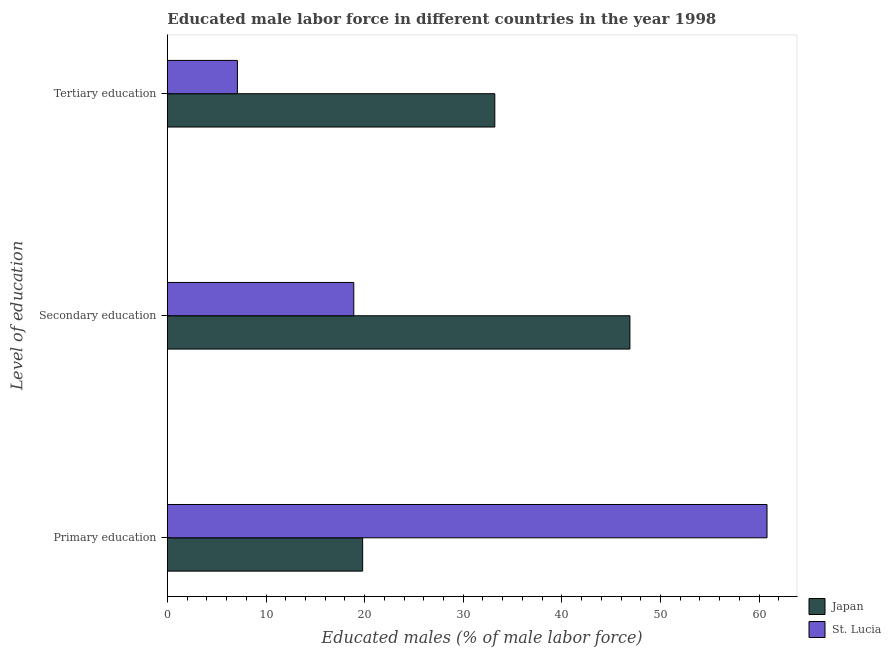How many different coloured bars are there?
Your answer should be compact. 2. How many bars are there on the 1st tick from the bottom?
Offer a very short reply. 2. What is the label of the 2nd group of bars from the top?
Give a very brief answer. Secondary education. What is the percentage of male labor force who received secondary education in St. Lucia?
Your answer should be very brief. 18.9. Across all countries, what is the maximum percentage of male labor force who received secondary education?
Make the answer very short. 46.9. Across all countries, what is the minimum percentage of male labor force who received primary education?
Offer a terse response. 19.8. In which country was the percentage of male labor force who received primary education maximum?
Your response must be concise. St. Lucia. What is the total percentage of male labor force who received primary education in the graph?
Make the answer very short. 80.6. What is the difference between the percentage of male labor force who received secondary education in Japan and that in St. Lucia?
Make the answer very short. 28. What is the difference between the percentage of male labor force who received tertiary education in Japan and the percentage of male labor force who received secondary education in St. Lucia?
Ensure brevity in your answer.  14.3. What is the average percentage of male labor force who received tertiary education per country?
Give a very brief answer. 20.15. What is the difference between the percentage of male labor force who received secondary education and percentage of male labor force who received tertiary education in Japan?
Give a very brief answer. 13.7. In how many countries, is the percentage of male labor force who received secondary education greater than 16 %?
Keep it short and to the point. 2. What is the ratio of the percentage of male labor force who received tertiary education in St. Lucia to that in Japan?
Provide a succinct answer. 0.21. Is the percentage of male labor force who received primary education in St. Lucia less than that in Japan?
Your answer should be very brief. No. What is the difference between the highest and the second highest percentage of male labor force who received secondary education?
Your answer should be compact. 28. What is the difference between the highest and the lowest percentage of male labor force who received tertiary education?
Keep it short and to the point. 26.1. In how many countries, is the percentage of male labor force who received secondary education greater than the average percentage of male labor force who received secondary education taken over all countries?
Keep it short and to the point. 1. Is the sum of the percentage of male labor force who received secondary education in Japan and St. Lucia greater than the maximum percentage of male labor force who received tertiary education across all countries?
Keep it short and to the point. Yes. What does the 2nd bar from the top in Secondary education represents?
Ensure brevity in your answer.  Japan. What does the 2nd bar from the bottom in Tertiary education represents?
Provide a short and direct response. St. Lucia. How many bars are there?
Ensure brevity in your answer.  6. Are all the bars in the graph horizontal?
Your answer should be compact. Yes. What is the difference between two consecutive major ticks on the X-axis?
Offer a very short reply. 10. Does the graph contain any zero values?
Ensure brevity in your answer.  No. Does the graph contain grids?
Your answer should be compact. No. What is the title of the graph?
Provide a succinct answer. Educated male labor force in different countries in the year 1998. What is the label or title of the X-axis?
Provide a succinct answer. Educated males (% of male labor force). What is the label or title of the Y-axis?
Keep it short and to the point. Level of education. What is the Educated males (% of male labor force) of Japan in Primary education?
Provide a short and direct response. 19.8. What is the Educated males (% of male labor force) of St. Lucia in Primary education?
Offer a very short reply. 60.8. What is the Educated males (% of male labor force) in Japan in Secondary education?
Your answer should be very brief. 46.9. What is the Educated males (% of male labor force) in St. Lucia in Secondary education?
Make the answer very short. 18.9. What is the Educated males (% of male labor force) of Japan in Tertiary education?
Make the answer very short. 33.2. What is the Educated males (% of male labor force) in St. Lucia in Tertiary education?
Offer a terse response. 7.1. Across all Level of education, what is the maximum Educated males (% of male labor force) in Japan?
Offer a very short reply. 46.9. Across all Level of education, what is the maximum Educated males (% of male labor force) of St. Lucia?
Your response must be concise. 60.8. Across all Level of education, what is the minimum Educated males (% of male labor force) of Japan?
Offer a very short reply. 19.8. Across all Level of education, what is the minimum Educated males (% of male labor force) of St. Lucia?
Your answer should be very brief. 7.1. What is the total Educated males (% of male labor force) in Japan in the graph?
Your answer should be very brief. 99.9. What is the total Educated males (% of male labor force) of St. Lucia in the graph?
Ensure brevity in your answer.  86.8. What is the difference between the Educated males (% of male labor force) in Japan in Primary education and that in Secondary education?
Ensure brevity in your answer.  -27.1. What is the difference between the Educated males (% of male labor force) in St. Lucia in Primary education and that in Secondary education?
Make the answer very short. 41.9. What is the difference between the Educated males (% of male labor force) of St. Lucia in Primary education and that in Tertiary education?
Ensure brevity in your answer.  53.7. What is the difference between the Educated males (% of male labor force) of Japan in Secondary education and that in Tertiary education?
Give a very brief answer. 13.7. What is the difference between the Educated males (% of male labor force) in Japan in Primary education and the Educated males (% of male labor force) in St. Lucia in Secondary education?
Your response must be concise. 0.9. What is the difference between the Educated males (% of male labor force) in Japan in Primary education and the Educated males (% of male labor force) in St. Lucia in Tertiary education?
Provide a succinct answer. 12.7. What is the difference between the Educated males (% of male labor force) of Japan in Secondary education and the Educated males (% of male labor force) of St. Lucia in Tertiary education?
Your answer should be very brief. 39.8. What is the average Educated males (% of male labor force) in Japan per Level of education?
Make the answer very short. 33.3. What is the average Educated males (% of male labor force) in St. Lucia per Level of education?
Offer a terse response. 28.93. What is the difference between the Educated males (% of male labor force) of Japan and Educated males (% of male labor force) of St. Lucia in Primary education?
Your response must be concise. -41. What is the difference between the Educated males (% of male labor force) of Japan and Educated males (% of male labor force) of St. Lucia in Secondary education?
Offer a very short reply. 28. What is the difference between the Educated males (% of male labor force) in Japan and Educated males (% of male labor force) in St. Lucia in Tertiary education?
Provide a succinct answer. 26.1. What is the ratio of the Educated males (% of male labor force) of Japan in Primary education to that in Secondary education?
Make the answer very short. 0.42. What is the ratio of the Educated males (% of male labor force) of St. Lucia in Primary education to that in Secondary education?
Provide a short and direct response. 3.22. What is the ratio of the Educated males (% of male labor force) in Japan in Primary education to that in Tertiary education?
Make the answer very short. 0.6. What is the ratio of the Educated males (% of male labor force) in St. Lucia in Primary education to that in Tertiary education?
Give a very brief answer. 8.56. What is the ratio of the Educated males (% of male labor force) in Japan in Secondary education to that in Tertiary education?
Your response must be concise. 1.41. What is the ratio of the Educated males (% of male labor force) in St. Lucia in Secondary education to that in Tertiary education?
Ensure brevity in your answer.  2.66. What is the difference between the highest and the second highest Educated males (% of male labor force) of St. Lucia?
Keep it short and to the point. 41.9. What is the difference between the highest and the lowest Educated males (% of male labor force) of Japan?
Your answer should be compact. 27.1. What is the difference between the highest and the lowest Educated males (% of male labor force) in St. Lucia?
Offer a terse response. 53.7. 